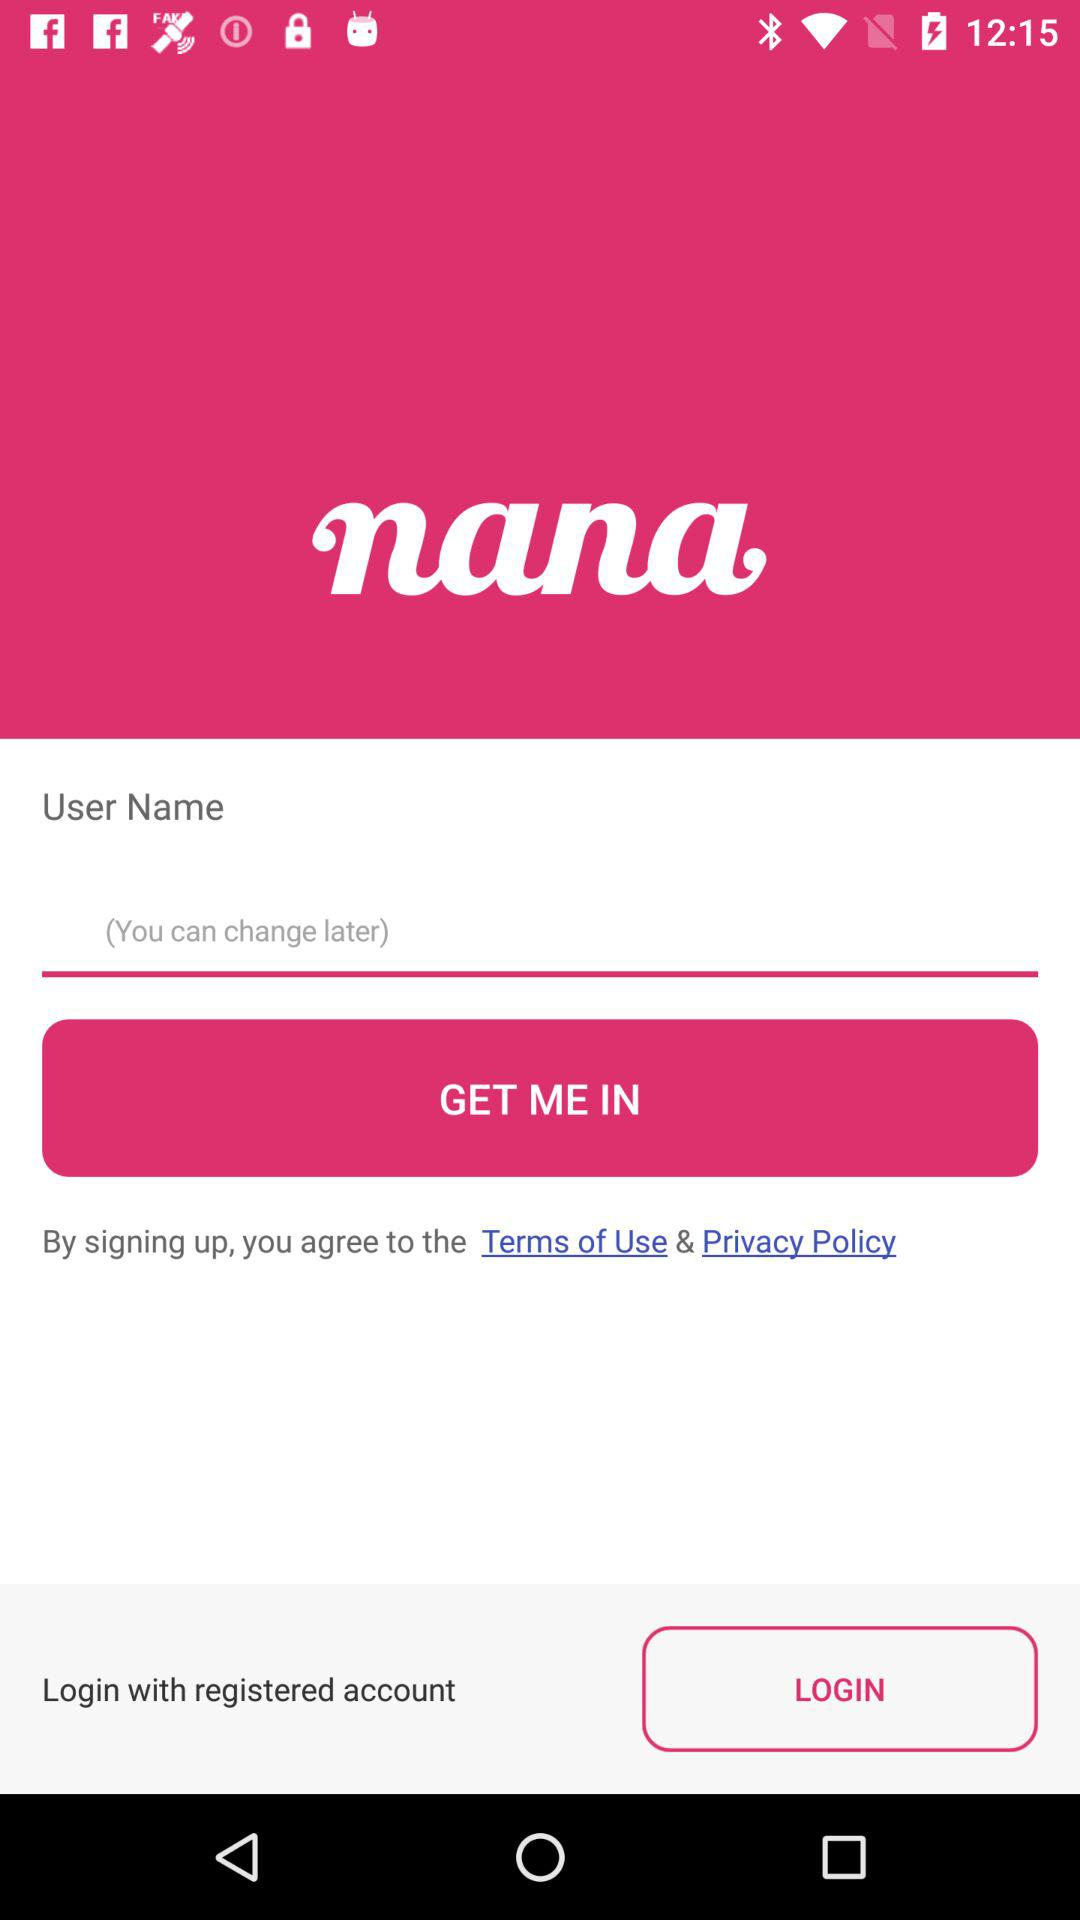What is the application name? The application name is "nana". 